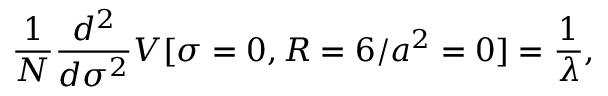<formula> <loc_0><loc_0><loc_500><loc_500>\frac { 1 } { N } \frac { d ^ { 2 } } { d \sigma ^ { 2 } } V [ \sigma = 0 , R = 6 / a ^ { 2 } = 0 ] = \frac { 1 } { \lambda } ,</formula> 